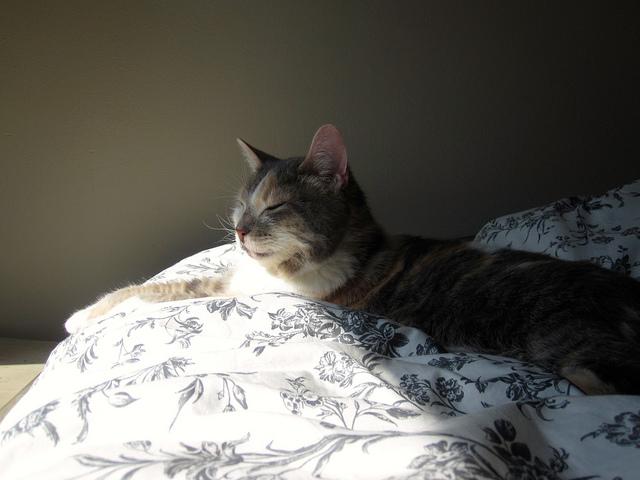Is this cat sleeping?
Answer briefly. Yes. Is this a cat?
Give a very brief answer. Yes. Is the cat sleeping?
Short answer required. Yes. What is shining on the cat's paws?
Concise answer only. Sun. What color is the wall?
Concise answer only. Gray. What is the cat sitting on?
Quick response, please. Bed. 